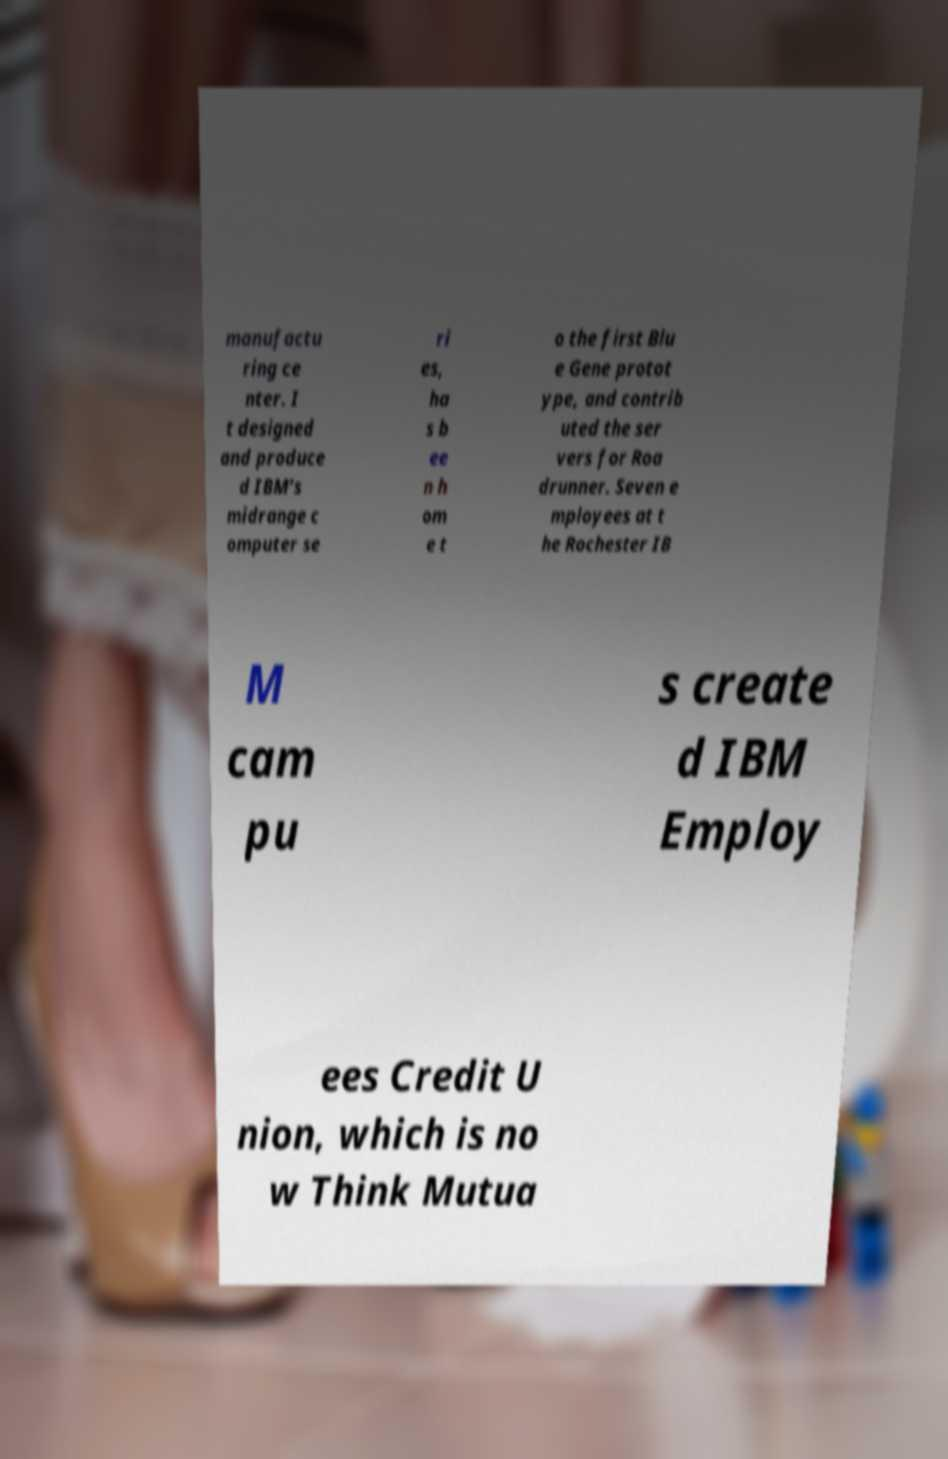Could you assist in decoding the text presented in this image and type it out clearly? manufactu ring ce nter. I t designed and produce d IBM’s midrange c omputer se ri es, ha s b ee n h om e t o the first Blu e Gene protot ype, and contrib uted the ser vers for Roa drunner. Seven e mployees at t he Rochester IB M cam pu s create d IBM Employ ees Credit U nion, which is no w Think Mutua 